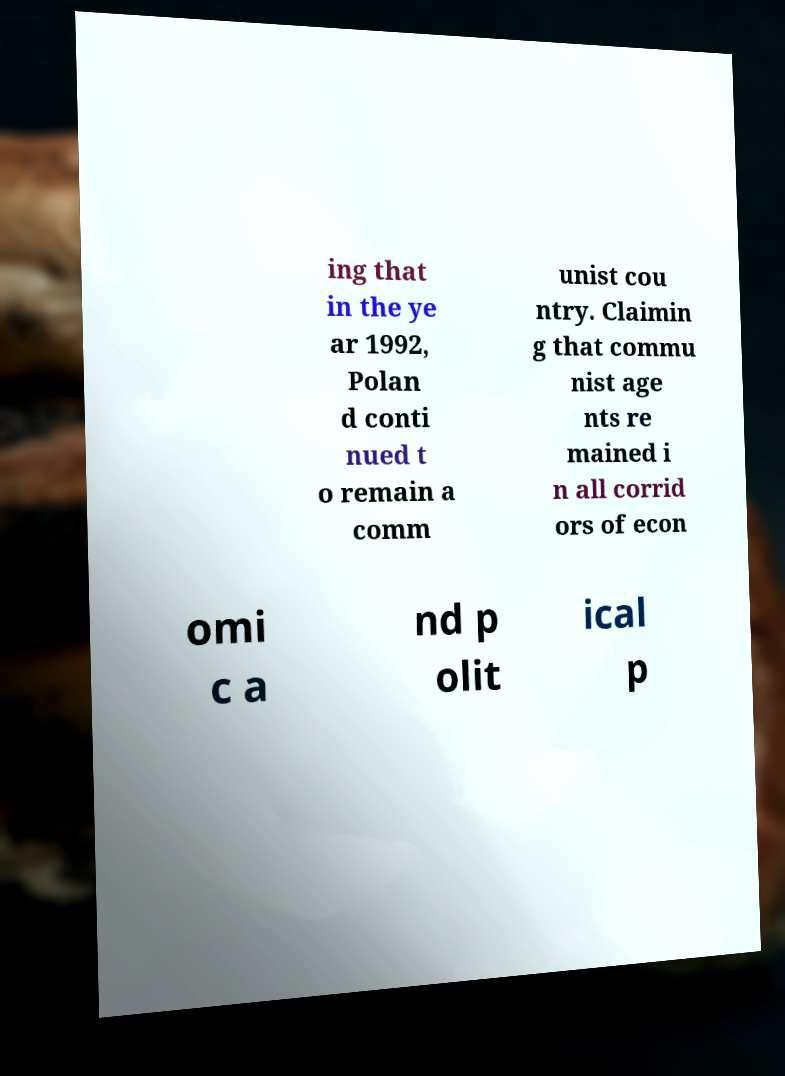Please identify and transcribe the text found in this image. ing that in the ye ar 1992, Polan d conti nued t o remain a comm unist cou ntry. Claimin g that commu nist age nts re mained i n all corrid ors of econ omi c a nd p olit ical p 